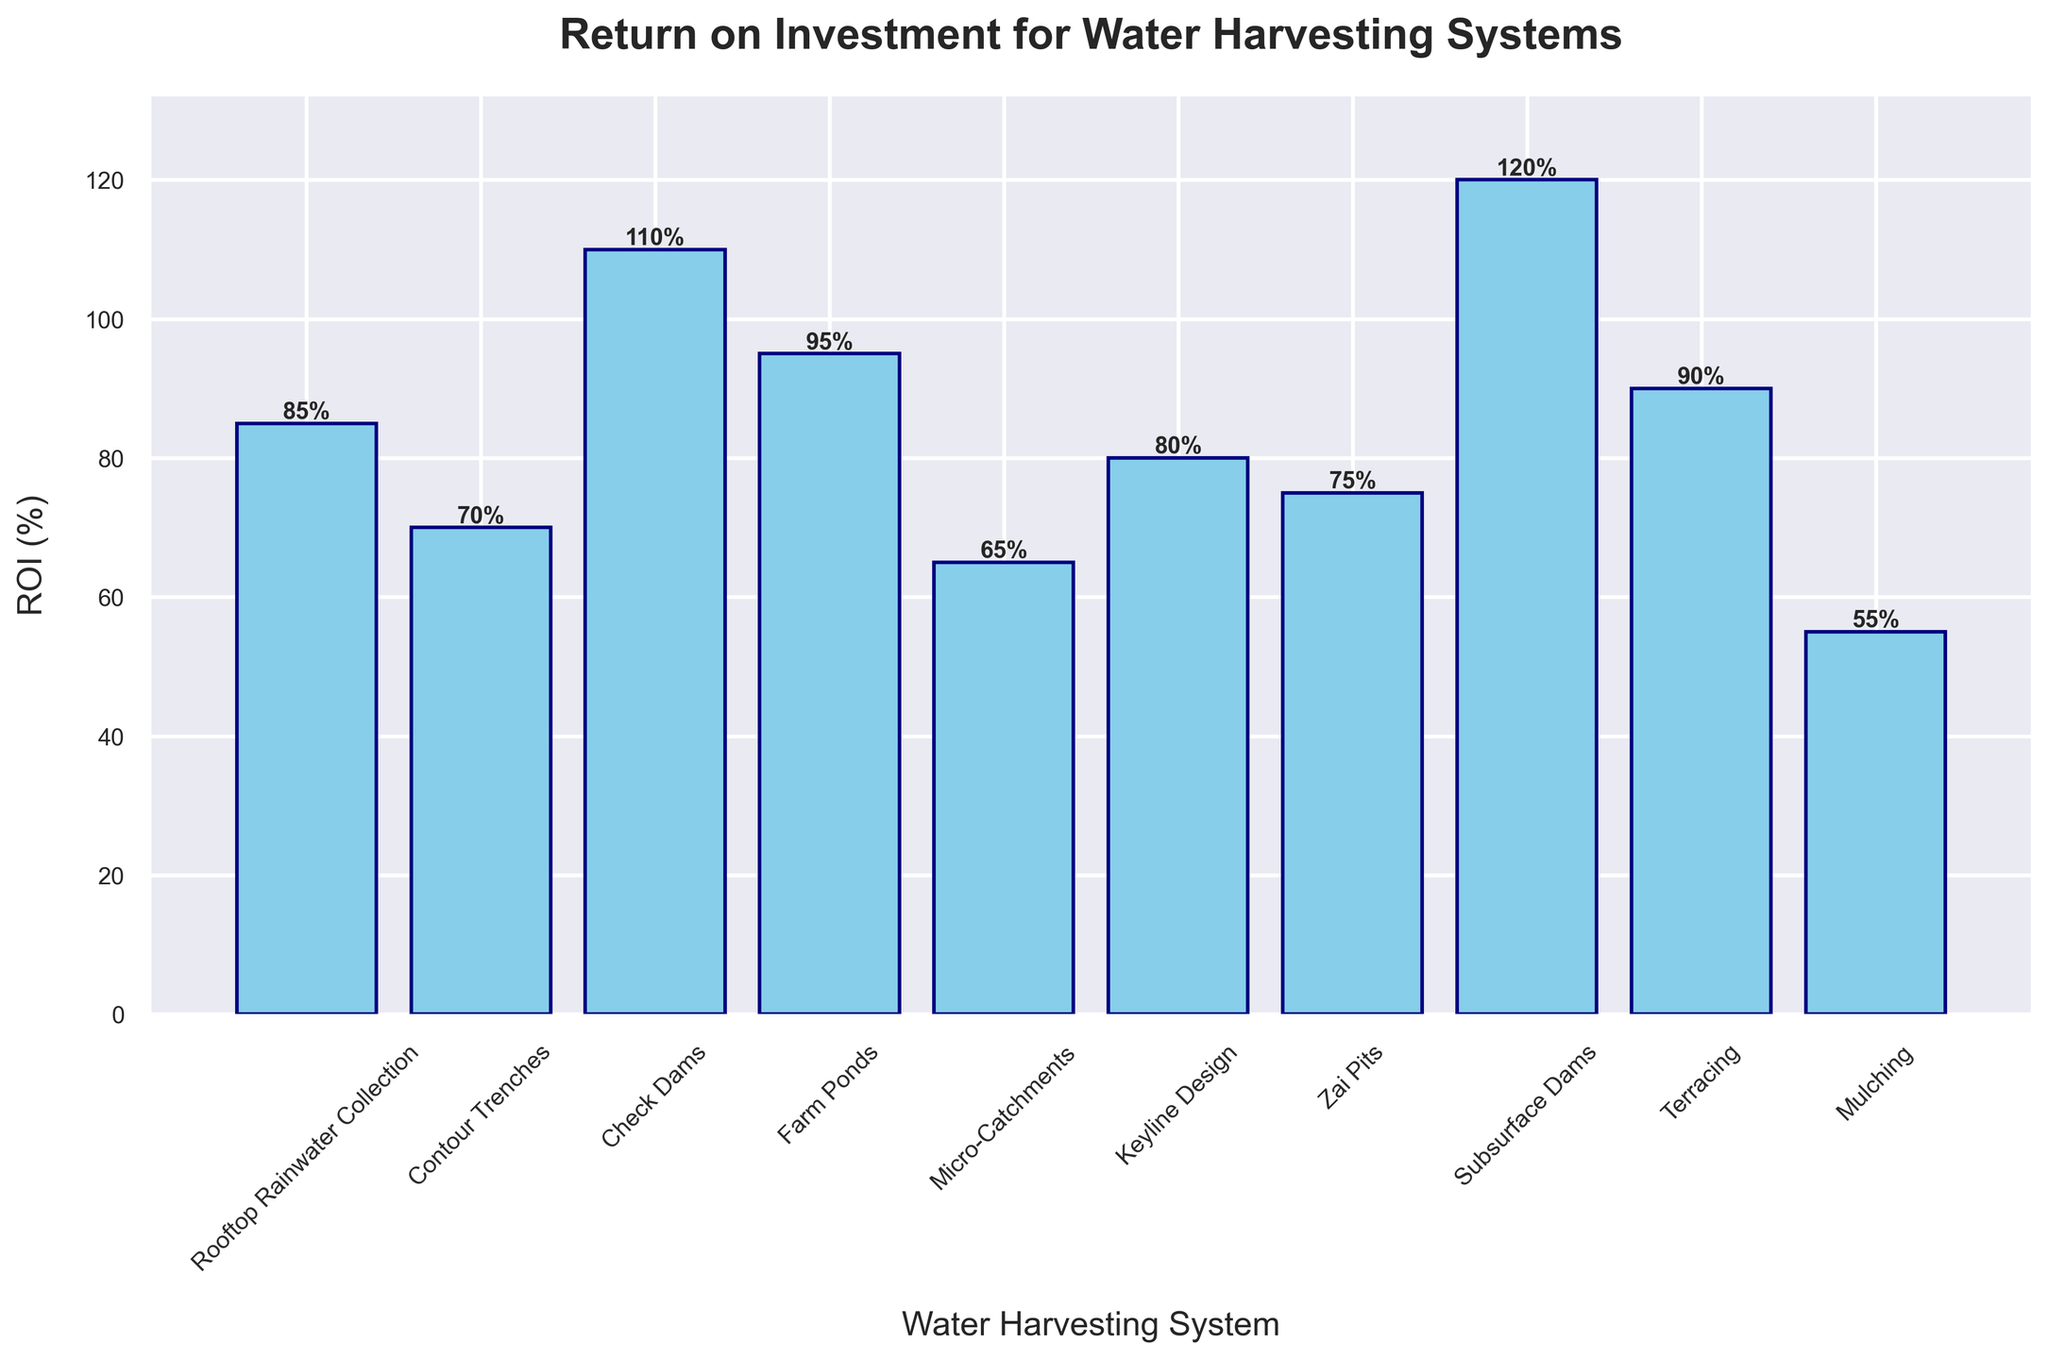What is the water harvesting system with the highest ROI? The height of the bars represents the ROI for each system. The bar for Subsurface Dams is the tallest. Therefore, Subsurface Dams have the highest ROI.
Answer: Subsurface Dams Which system has a lower ROI, Check Dams or Keyline Design? By comparing the heights of the bars labeled Check Dams and Keyline Design, Check Dams have a higher bar indicating a higher ROI than Keyline Design.
Answer: Keyline Design How many systems have an ROI above 90%? Check the height of each bar and identify those exceeding the 90% line on the y-axis. The systems are Subsurface Dams, Farm Ponds, Check Dams, and Terracing. There are four such systems.
Answer: 4 What is the difference in ROI between Check Dams and Mulching? Check the heights of the bars for Check Dams (110%) and Mulching (55%), then subtract the ROI of Mulching from that of Check Dams: 110% - 55% = 55%.
Answer: 55% Which systems have an ROI between 60% and 80%? Identify the bars whose height falls within the range of 60% to 80%, which are Micro-Catchments (65%), Zai Pits (75%), and Contour Trenches (70%).
Answer: Micro-Catchments, Zai Pits, Contour Trenches What is the average ROI of all the systems that have an ROI of 85% or higher? Identify the systems with an ROI of 85% or higher: Rooftop Rainwater Collection (85%), Farm Ponds (95%), Check Dams (110%), and Subsurface Dams (120%), then calculate their average by summing their ROIs and dividing by the count: (85 + 95 + 110 + 120) / 4 = 102.5%.
Answer: 102.5% Are there more systems with ROI below 70% or systems with ROI above 100%? Count the systems with ROI below 70% (Micro-Catchments and Mulching) and those with ROI above 100% (Check Dams and Subsurface Dams). There are two systems in each category, so the numbers are equal.
Answer: Equal Which system(s) have the lowest ROI? The height of the bars represents the ROI for each system. The bar for Mulching is the shortest, indicating the lowest ROI.
Answer: Mulching What is the combined ROI of Zai Pits and Keyline Design? Sum the ROIs of Zai Pits (75%) and Keyline Design (80%): 75% + 80% = 155%.
Answer: 155% What is the median ROI of all the systems? List the ROIs in ascending order: [55, 65, 70, 75, 80, 85, 90, 95, 110, 120]. The median is the average of the 5th and 6th values in this sorted list: (80 + 85) / 2 = 82.5%.
Answer: 82.5% 